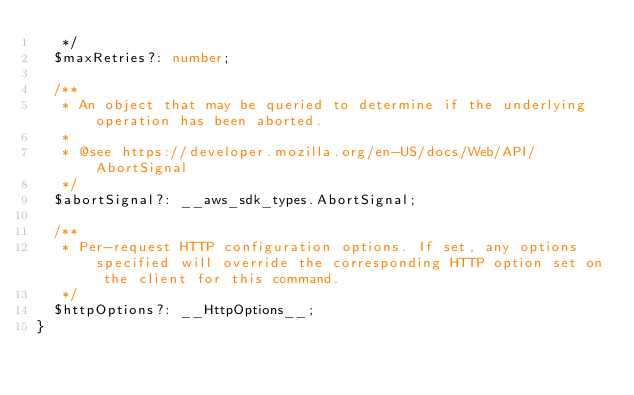<code> <loc_0><loc_0><loc_500><loc_500><_TypeScript_>   */
  $maxRetries?: number;

  /**
   * An object that may be queried to determine if the underlying operation has been aborted.
   *
   * @see https://developer.mozilla.org/en-US/docs/Web/API/AbortSignal
   */
  $abortSignal?: __aws_sdk_types.AbortSignal;

  /**
   * Per-request HTTP configuration options. If set, any options specified will override the corresponding HTTP option set on the client for this command.
   */
  $httpOptions?: __HttpOptions__;
}
</code> 